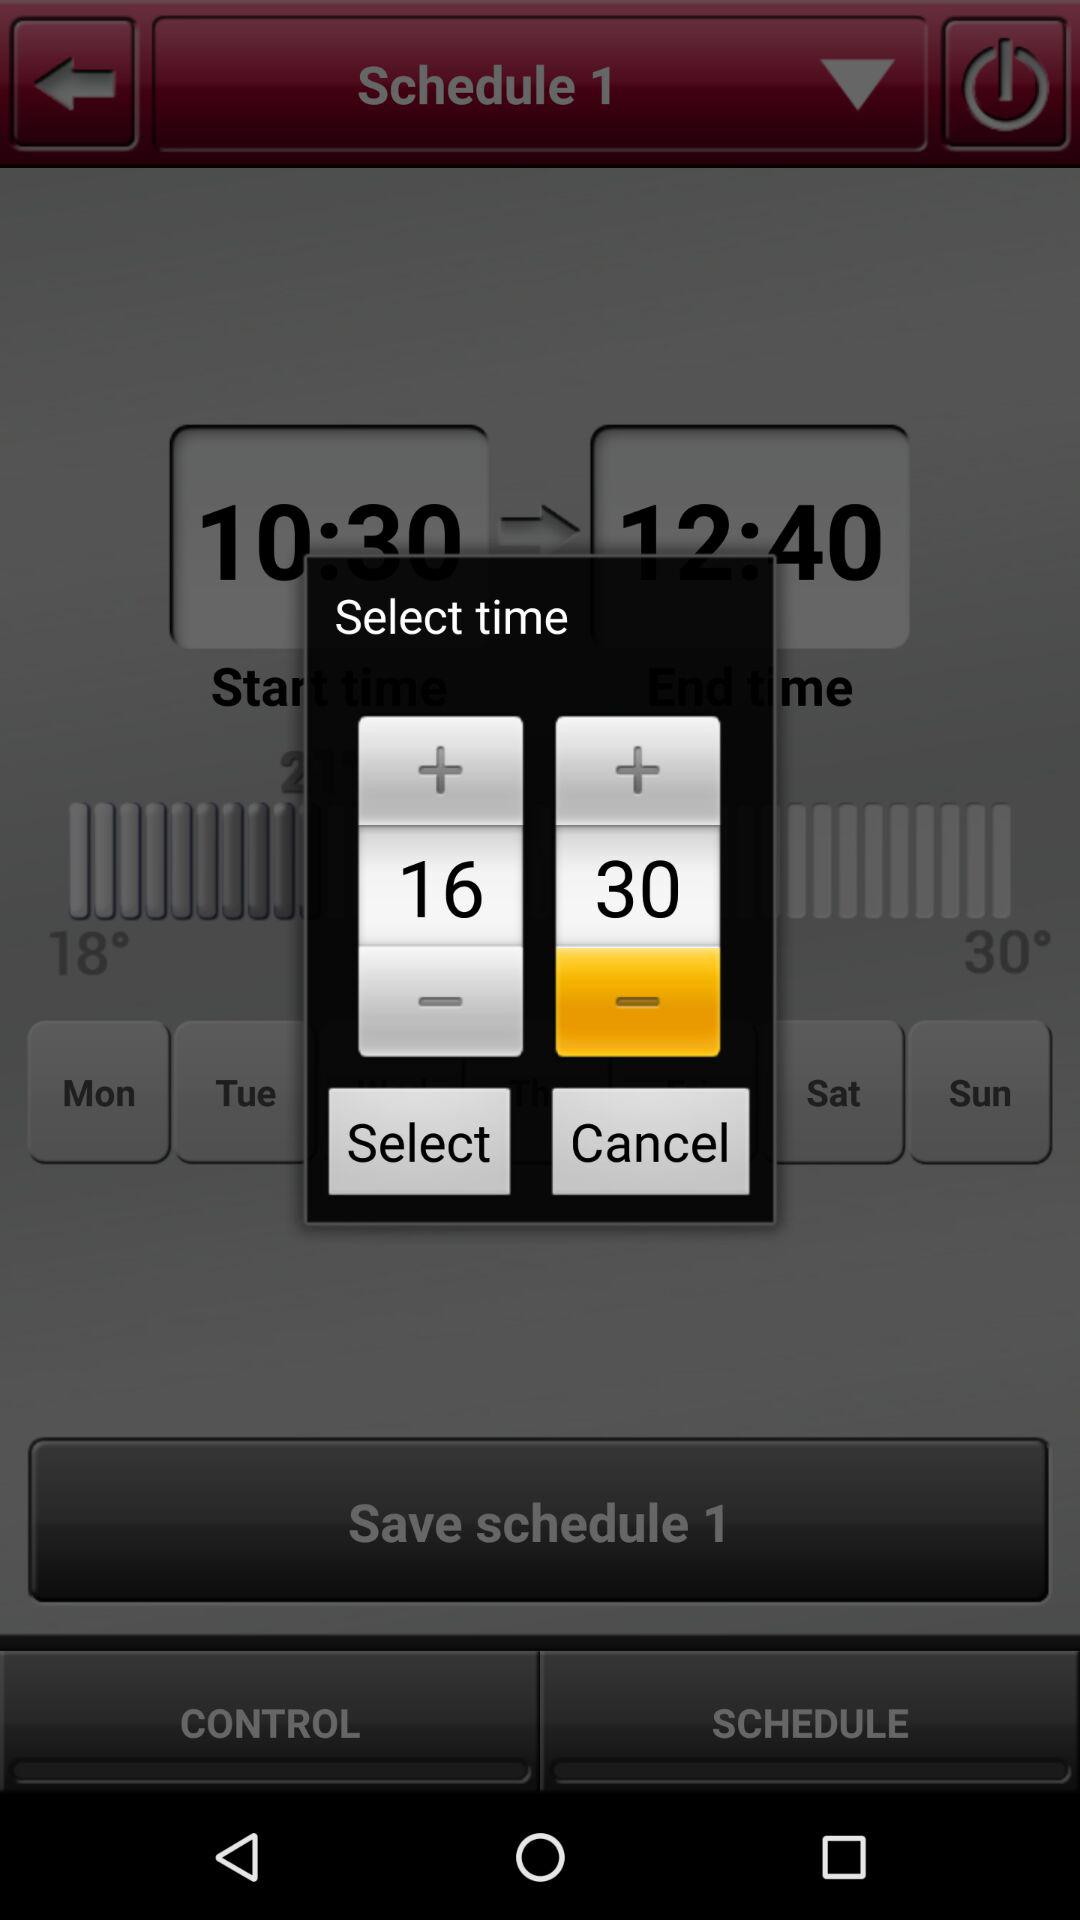What is the selected time? The selected time is 16:30. 